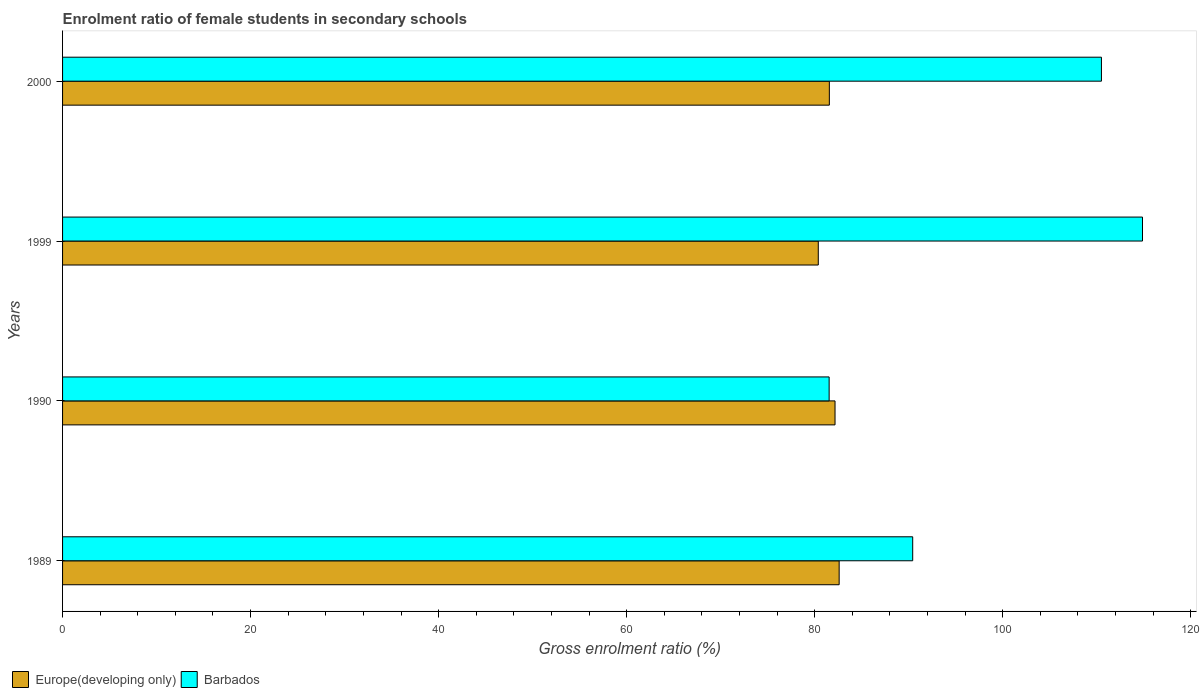How many different coloured bars are there?
Offer a very short reply. 2. How many groups of bars are there?
Offer a terse response. 4. What is the enrolment ratio of female students in secondary schools in Europe(developing only) in 2000?
Offer a very short reply. 81.56. Across all years, what is the maximum enrolment ratio of female students in secondary schools in Barbados?
Give a very brief answer. 114.87. Across all years, what is the minimum enrolment ratio of female students in secondary schools in Europe(developing only)?
Ensure brevity in your answer.  80.39. In which year was the enrolment ratio of female students in secondary schools in Barbados minimum?
Provide a succinct answer. 1990. What is the total enrolment ratio of female students in secondary schools in Barbados in the graph?
Your answer should be very brief. 397.34. What is the difference between the enrolment ratio of female students in secondary schools in Europe(developing only) in 1999 and that in 2000?
Keep it short and to the point. -1.18. What is the difference between the enrolment ratio of female students in secondary schools in Europe(developing only) in 1990 and the enrolment ratio of female students in secondary schools in Barbados in 1989?
Keep it short and to the point. -8.26. What is the average enrolment ratio of female students in secondary schools in Barbados per year?
Offer a terse response. 99.34. In the year 1999, what is the difference between the enrolment ratio of female students in secondary schools in Europe(developing only) and enrolment ratio of female students in secondary schools in Barbados?
Give a very brief answer. -34.49. What is the ratio of the enrolment ratio of female students in secondary schools in Europe(developing only) in 1989 to that in 1999?
Provide a short and direct response. 1.03. Is the difference between the enrolment ratio of female students in secondary schools in Europe(developing only) in 1990 and 2000 greater than the difference between the enrolment ratio of female students in secondary schools in Barbados in 1990 and 2000?
Offer a very short reply. Yes. What is the difference between the highest and the second highest enrolment ratio of female students in secondary schools in Europe(developing only)?
Keep it short and to the point. 0.44. What is the difference between the highest and the lowest enrolment ratio of female students in secondary schools in Barbados?
Offer a terse response. 33.33. In how many years, is the enrolment ratio of female students in secondary schools in Europe(developing only) greater than the average enrolment ratio of female students in secondary schools in Europe(developing only) taken over all years?
Provide a succinct answer. 2. Is the sum of the enrolment ratio of female students in secondary schools in Barbados in 1989 and 2000 greater than the maximum enrolment ratio of female students in secondary schools in Europe(developing only) across all years?
Make the answer very short. Yes. What does the 2nd bar from the top in 1999 represents?
Ensure brevity in your answer.  Europe(developing only). What does the 2nd bar from the bottom in 2000 represents?
Provide a short and direct response. Barbados. What is the difference between two consecutive major ticks on the X-axis?
Ensure brevity in your answer.  20. Does the graph contain any zero values?
Provide a short and direct response. No. Where does the legend appear in the graph?
Your answer should be very brief. Bottom left. How many legend labels are there?
Provide a succinct answer. 2. How are the legend labels stacked?
Your answer should be compact. Horizontal. What is the title of the graph?
Your answer should be very brief. Enrolment ratio of female students in secondary schools. What is the Gross enrolment ratio (%) of Europe(developing only) in 1989?
Provide a short and direct response. 82.61. What is the Gross enrolment ratio (%) in Barbados in 1989?
Make the answer very short. 90.43. What is the Gross enrolment ratio (%) in Europe(developing only) in 1990?
Your answer should be very brief. 82.17. What is the Gross enrolment ratio (%) of Barbados in 1990?
Offer a very short reply. 81.54. What is the Gross enrolment ratio (%) in Europe(developing only) in 1999?
Make the answer very short. 80.39. What is the Gross enrolment ratio (%) of Barbados in 1999?
Keep it short and to the point. 114.87. What is the Gross enrolment ratio (%) in Europe(developing only) in 2000?
Offer a very short reply. 81.56. What is the Gross enrolment ratio (%) in Barbados in 2000?
Ensure brevity in your answer.  110.5. Across all years, what is the maximum Gross enrolment ratio (%) in Europe(developing only)?
Keep it short and to the point. 82.61. Across all years, what is the maximum Gross enrolment ratio (%) in Barbados?
Keep it short and to the point. 114.87. Across all years, what is the minimum Gross enrolment ratio (%) of Europe(developing only)?
Ensure brevity in your answer.  80.39. Across all years, what is the minimum Gross enrolment ratio (%) of Barbados?
Ensure brevity in your answer.  81.54. What is the total Gross enrolment ratio (%) of Europe(developing only) in the graph?
Make the answer very short. 326.72. What is the total Gross enrolment ratio (%) of Barbados in the graph?
Keep it short and to the point. 397.34. What is the difference between the Gross enrolment ratio (%) of Europe(developing only) in 1989 and that in 1990?
Keep it short and to the point. 0.44. What is the difference between the Gross enrolment ratio (%) in Barbados in 1989 and that in 1990?
Provide a short and direct response. 8.89. What is the difference between the Gross enrolment ratio (%) of Europe(developing only) in 1989 and that in 1999?
Make the answer very short. 2.22. What is the difference between the Gross enrolment ratio (%) in Barbados in 1989 and that in 1999?
Your response must be concise. -24.44. What is the difference between the Gross enrolment ratio (%) in Europe(developing only) in 1989 and that in 2000?
Give a very brief answer. 1.04. What is the difference between the Gross enrolment ratio (%) of Barbados in 1989 and that in 2000?
Provide a short and direct response. -20.08. What is the difference between the Gross enrolment ratio (%) of Europe(developing only) in 1990 and that in 1999?
Provide a short and direct response. 1.78. What is the difference between the Gross enrolment ratio (%) in Barbados in 1990 and that in 1999?
Give a very brief answer. -33.33. What is the difference between the Gross enrolment ratio (%) of Europe(developing only) in 1990 and that in 2000?
Make the answer very short. 0.61. What is the difference between the Gross enrolment ratio (%) in Barbados in 1990 and that in 2000?
Offer a terse response. -28.96. What is the difference between the Gross enrolment ratio (%) of Europe(developing only) in 1999 and that in 2000?
Ensure brevity in your answer.  -1.18. What is the difference between the Gross enrolment ratio (%) in Barbados in 1999 and that in 2000?
Provide a short and direct response. 4.37. What is the difference between the Gross enrolment ratio (%) in Europe(developing only) in 1989 and the Gross enrolment ratio (%) in Barbados in 1990?
Your response must be concise. 1.06. What is the difference between the Gross enrolment ratio (%) of Europe(developing only) in 1989 and the Gross enrolment ratio (%) of Barbados in 1999?
Give a very brief answer. -32.27. What is the difference between the Gross enrolment ratio (%) in Europe(developing only) in 1989 and the Gross enrolment ratio (%) in Barbados in 2000?
Ensure brevity in your answer.  -27.9. What is the difference between the Gross enrolment ratio (%) in Europe(developing only) in 1990 and the Gross enrolment ratio (%) in Barbados in 1999?
Your answer should be compact. -32.71. What is the difference between the Gross enrolment ratio (%) of Europe(developing only) in 1990 and the Gross enrolment ratio (%) of Barbados in 2000?
Provide a succinct answer. -28.34. What is the difference between the Gross enrolment ratio (%) of Europe(developing only) in 1999 and the Gross enrolment ratio (%) of Barbados in 2000?
Give a very brief answer. -30.12. What is the average Gross enrolment ratio (%) in Europe(developing only) per year?
Provide a short and direct response. 81.68. What is the average Gross enrolment ratio (%) in Barbados per year?
Give a very brief answer. 99.34. In the year 1989, what is the difference between the Gross enrolment ratio (%) in Europe(developing only) and Gross enrolment ratio (%) in Barbados?
Your response must be concise. -7.82. In the year 1990, what is the difference between the Gross enrolment ratio (%) of Europe(developing only) and Gross enrolment ratio (%) of Barbados?
Ensure brevity in your answer.  0.63. In the year 1999, what is the difference between the Gross enrolment ratio (%) of Europe(developing only) and Gross enrolment ratio (%) of Barbados?
Offer a terse response. -34.49. In the year 2000, what is the difference between the Gross enrolment ratio (%) of Europe(developing only) and Gross enrolment ratio (%) of Barbados?
Your answer should be very brief. -28.94. What is the ratio of the Gross enrolment ratio (%) in Europe(developing only) in 1989 to that in 1990?
Give a very brief answer. 1.01. What is the ratio of the Gross enrolment ratio (%) of Barbados in 1989 to that in 1990?
Provide a succinct answer. 1.11. What is the ratio of the Gross enrolment ratio (%) of Europe(developing only) in 1989 to that in 1999?
Give a very brief answer. 1.03. What is the ratio of the Gross enrolment ratio (%) of Barbados in 1989 to that in 1999?
Give a very brief answer. 0.79. What is the ratio of the Gross enrolment ratio (%) of Europe(developing only) in 1989 to that in 2000?
Provide a short and direct response. 1.01. What is the ratio of the Gross enrolment ratio (%) in Barbados in 1989 to that in 2000?
Keep it short and to the point. 0.82. What is the ratio of the Gross enrolment ratio (%) in Europe(developing only) in 1990 to that in 1999?
Provide a short and direct response. 1.02. What is the ratio of the Gross enrolment ratio (%) in Barbados in 1990 to that in 1999?
Your answer should be very brief. 0.71. What is the ratio of the Gross enrolment ratio (%) in Europe(developing only) in 1990 to that in 2000?
Provide a short and direct response. 1.01. What is the ratio of the Gross enrolment ratio (%) in Barbados in 1990 to that in 2000?
Make the answer very short. 0.74. What is the ratio of the Gross enrolment ratio (%) of Europe(developing only) in 1999 to that in 2000?
Provide a short and direct response. 0.99. What is the ratio of the Gross enrolment ratio (%) of Barbados in 1999 to that in 2000?
Give a very brief answer. 1.04. What is the difference between the highest and the second highest Gross enrolment ratio (%) in Europe(developing only)?
Provide a short and direct response. 0.44. What is the difference between the highest and the second highest Gross enrolment ratio (%) in Barbados?
Keep it short and to the point. 4.37. What is the difference between the highest and the lowest Gross enrolment ratio (%) in Europe(developing only)?
Ensure brevity in your answer.  2.22. What is the difference between the highest and the lowest Gross enrolment ratio (%) of Barbados?
Ensure brevity in your answer.  33.33. 